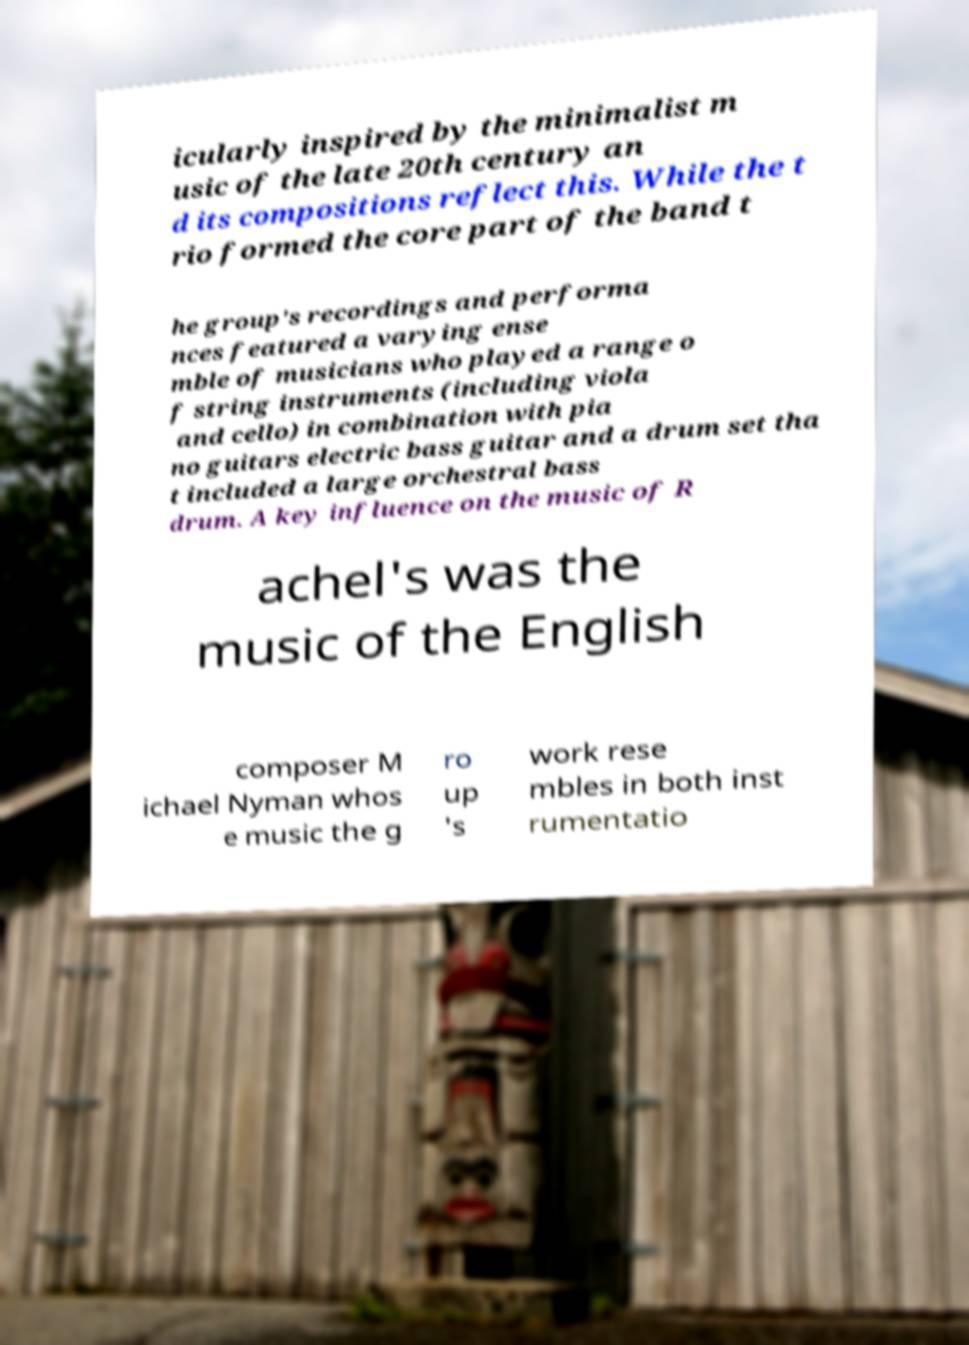Can you accurately transcribe the text from the provided image for me? icularly inspired by the minimalist m usic of the late 20th century an d its compositions reflect this. While the t rio formed the core part of the band t he group's recordings and performa nces featured a varying ense mble of musicians who played a range o f string instruments (including viola and cello) in combination with pia no guitars electric bass guitar and a drum set tha t included a large orchestral bass drum. A key influence on the music of R achel's was the music of the English composer M ichael Nyman whos e music the g ro up 's work rese mbles in both inst rumentatio 